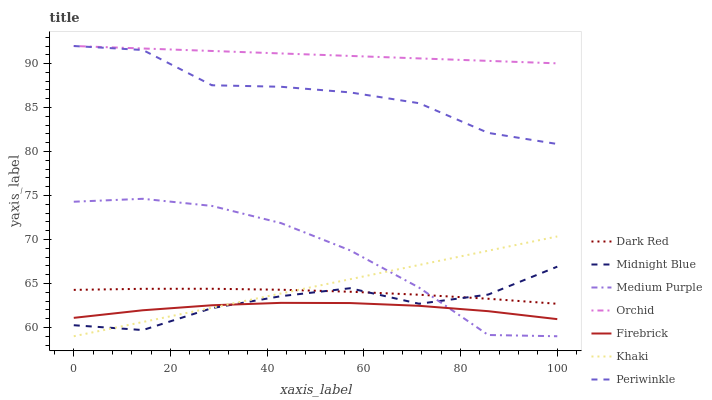Does Firebrick have the minimum area under the curve?
Answer yes or no. Yes. Does Orchid have the maximum area under the curve?
Answer yes or no. Yes. Does Midnight Blue have the minimum area under the curve?
Answer yes or no. No. Does Midnight Blue have the maximum area under the curve?
Answer yes or no. No. Is Khaki the smoothest?
Answer yes or no. Yes. Is Periwinkle the roughest?
Answer yes or no. Yes. Is Midnight Blue the smoothest?
Answer yes or no. No. Is Midnight Blue the roughest?
Answer yes or no. No. Does Khaki have the lowest value?
Answer yes or no. Yes. Does Midnight Blue have the lowest value?
Answer yes or no. No. Does Orchid have the highest value?
Answer yes or no. Yes. Does Midnight Blue have the highest value?
Answer yes or no. No. Is Khaki less than Periwinkle?
Answer yes or no. Yes. Is Periwinkle greater than Medium Purple?
Answer yes or no. Yes. Does Midnight Blue intersect Firebrick?
Answer yes or no. Yes. Is Midnight Blue less than Firebrick?
Answer yes or no. No. Is Midnight Blue greater than Firebrick?
Answer yes or no. No. Does Khaki intersect Periwinkle?
Answer yes or no. No. 